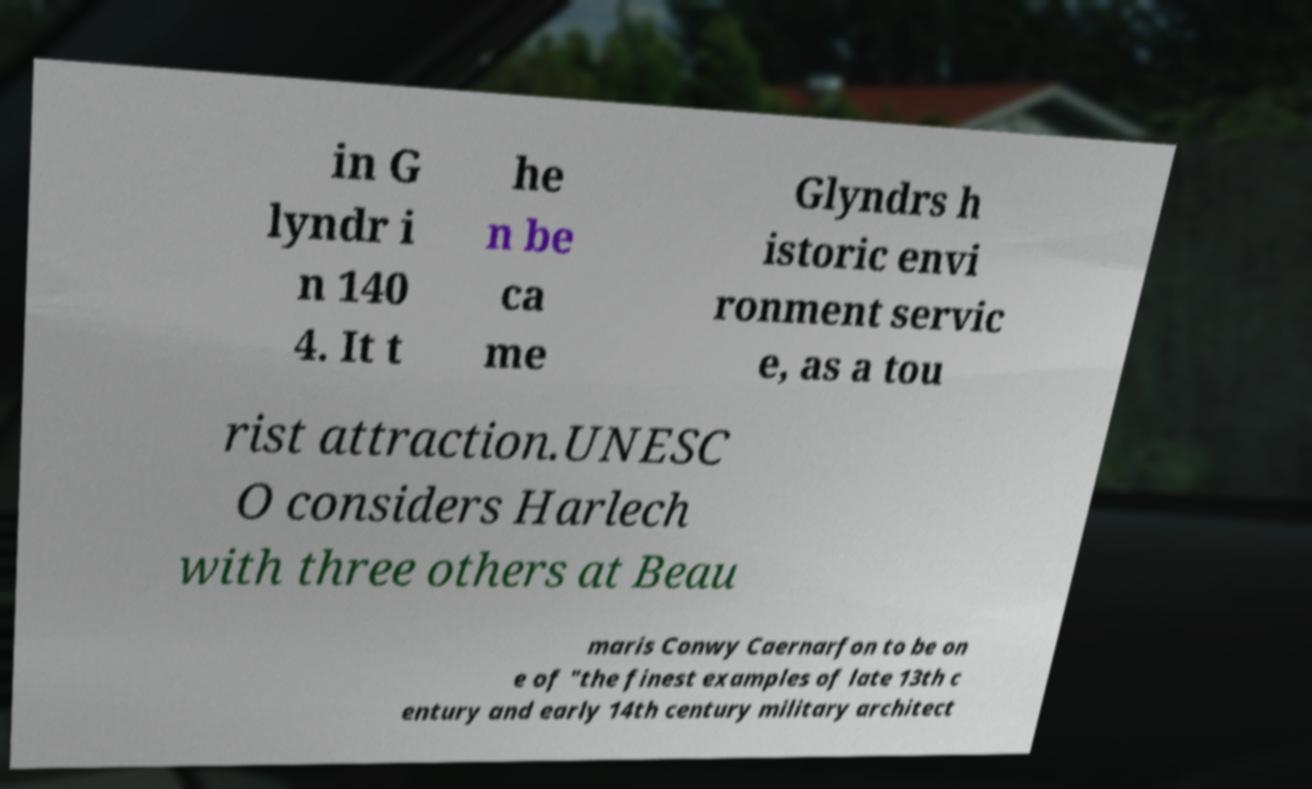There's text embedded in this image that I need extracted. Can you transcribe it verbatim? in G lyndr i n 140 4. It t he n be ca me Glyndrs h istoric envi ronment servic e, as a tou rist attraction.UNESC O considers Harlech with three others at Beau maris Conwy Caernarfon to be on e of "the finest examples of late 13th c entury and early 14th century military architect 